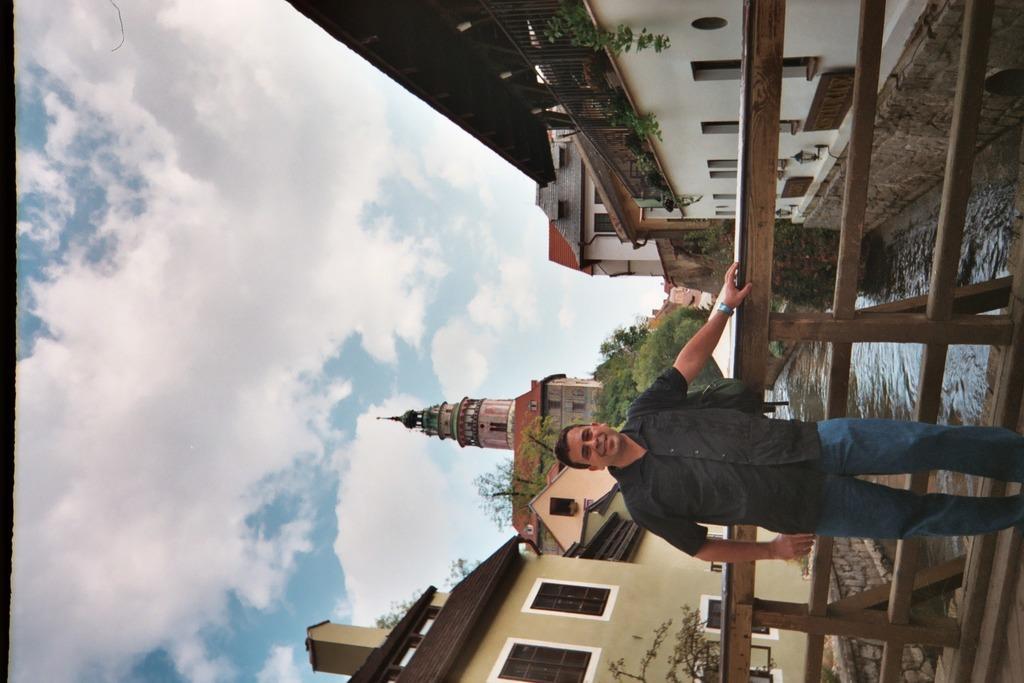How would you summarize this image in a sentence or two? This image consists of a man wearing a black shirt and blue jeans. Behind him, there is a railing made up of wood. At the bottom, there is water. On the left and right, there are buildings. In the middle, there are trees. At the top, there are clouds in the sky. 